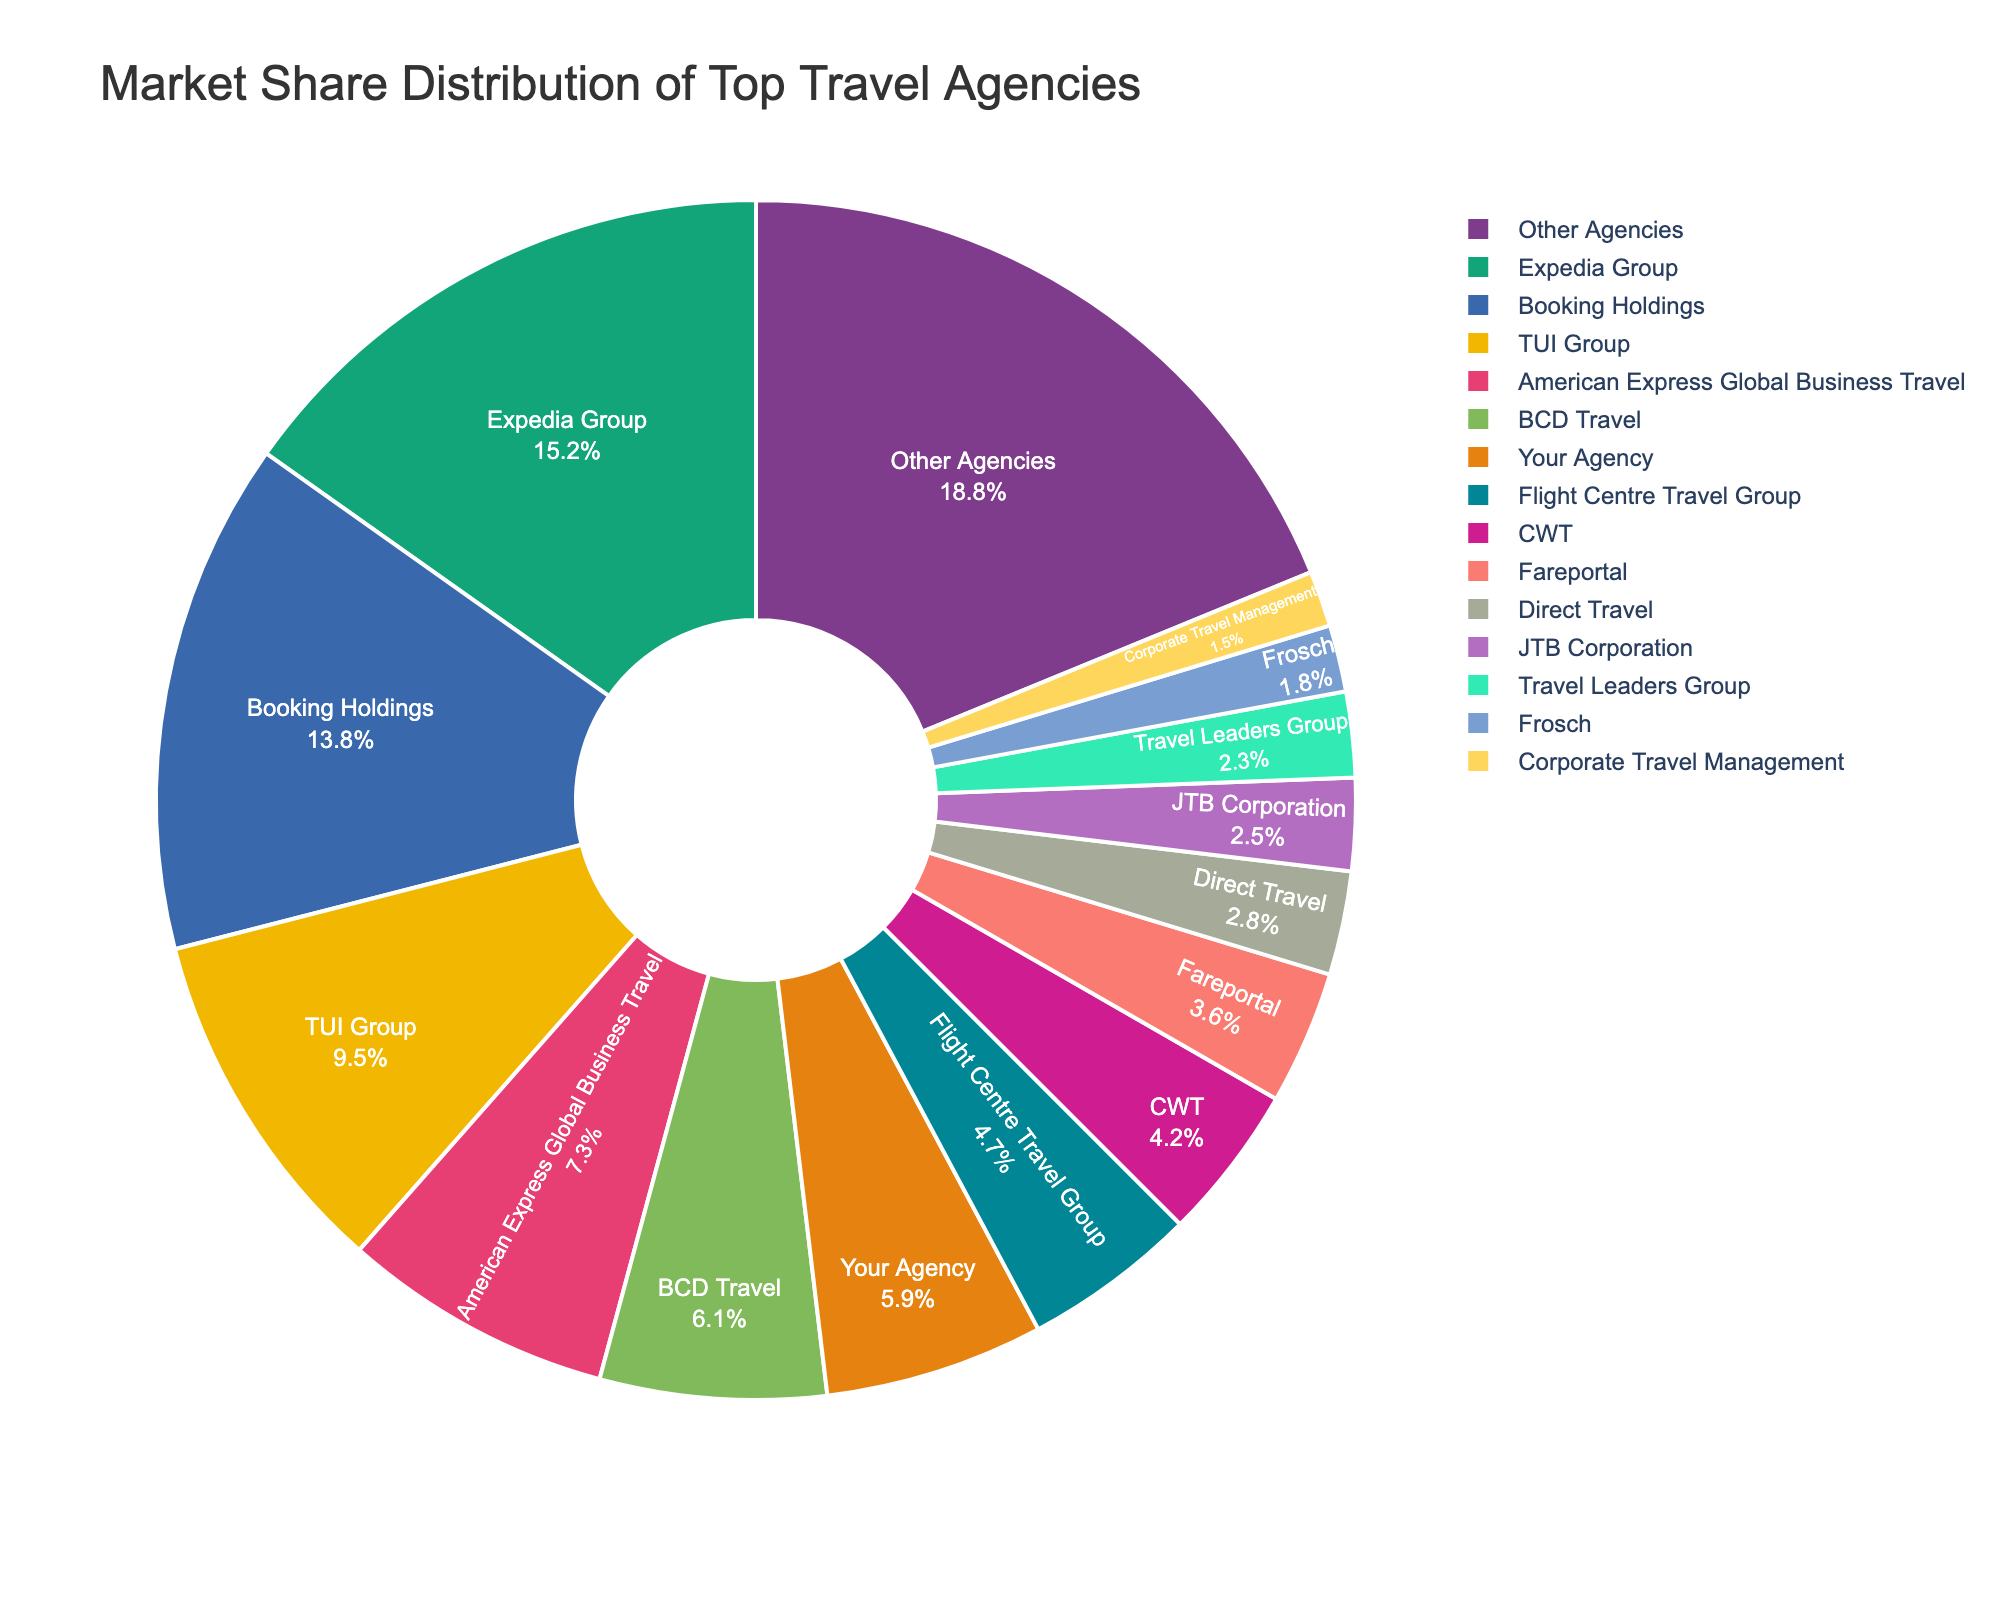Which travel agency has the highest market share? The highest market share is represented by the largest segment in the pie chart. Here, it corresponds to the Expedia Group.
Answer: Expedia Group What is the combined market share of Booking Holdings and TUI Group? Add the market share percentages of Booking Holdings (13.8%) and TUI Group (9.5%). The sum is 13.8% + 9.5% = 23.3%.
Answer: 23.3% How does Your Agency's market share compare to that of American Express Global Business Travel? Compare the market share percentages: Your Agency has 5.9%, while American Express Global Business Travel has 7.3%. American Express Global Business Travel has a higher market share.
Answer: American Express Global Business Travel has a higher market share What percentage of the market do the top three agencies control together? Sum the market shares of the top three agencies: Expedia Group (15.2%), Booking Holdings (13.8%), and TUI Group (9.5%). The total is 15.2% + 13.8% + 9.5% = 38.5%.
Answer: 38.5% Is the market share of CWT greater than that of Fareportal? Compare the two market shares: CWT has 4.2%, and Fareportal has 3.6%. CWT has a higher market share.
Answer: Yes, CWT By how much does BCD Travel's market share exceed that of Flight Centre Travel Group? Subtract Flight Centre Travel Group's market share (4.7%) from BCD Travel's market share (6.1%). The difference is 6.1% - 4.7% = 1.4%.
Answer: 1.4% What is the combined market share of agencies with less than 5%? Identify agencies with less than 5% market share and sum their percentages: Your Agency (5.9%) is excluded, while Flight Centre Travel Group (4.7%), CWT (4.2%), Fareportal (3.6%), Direct Travel (2.8%), JTB Corporation (2.5%), Travel Leaders Group (2.3%), Frosch (1.8%), and Corporate Travel Management (1.5%) are included. The total is 4.7% + 4.2% + 3.6% + 2.8% + 2.5% + 2.3% + 1.8% + 1.5% = 23.4%.
Answer: 23.4% How does the market share of Other Agencies compare to that of the direct competitor (Your Agency)? Other Agencies have 18.8% market share, whereas Your Agency has 5.9%. Other Agencies have significantly higher market share.
Answer: Other Agencies have a higher market share What is the median market share of the listed travel agencies (excluding Other Agencies)? To find the median, organize the market shares in ascending order and find the middle value. The ordered values are: 1.5%, 1.8%, 2.3%, 2.5%, 2.8%, 3.6%, 4.2%, 4.7%, 5.9%, 6.1%, 7.3%, 9.5%, 13.8%, 15.2%. The median is the average of the 7th and 8th values: (4.2% + 4.7%)/2 = 4.45%.
Answer: 4.45% In terms of market share, which agency is closest to Your Agency? Identify the agencies with market shares closest to Your Agency (5.9%). Direct competitors are BCD Travel (6.1%) and Flight Centre Travel Group (4.7%). BCD Travel is closest with 6.1%.
Answer: BCD Travel 